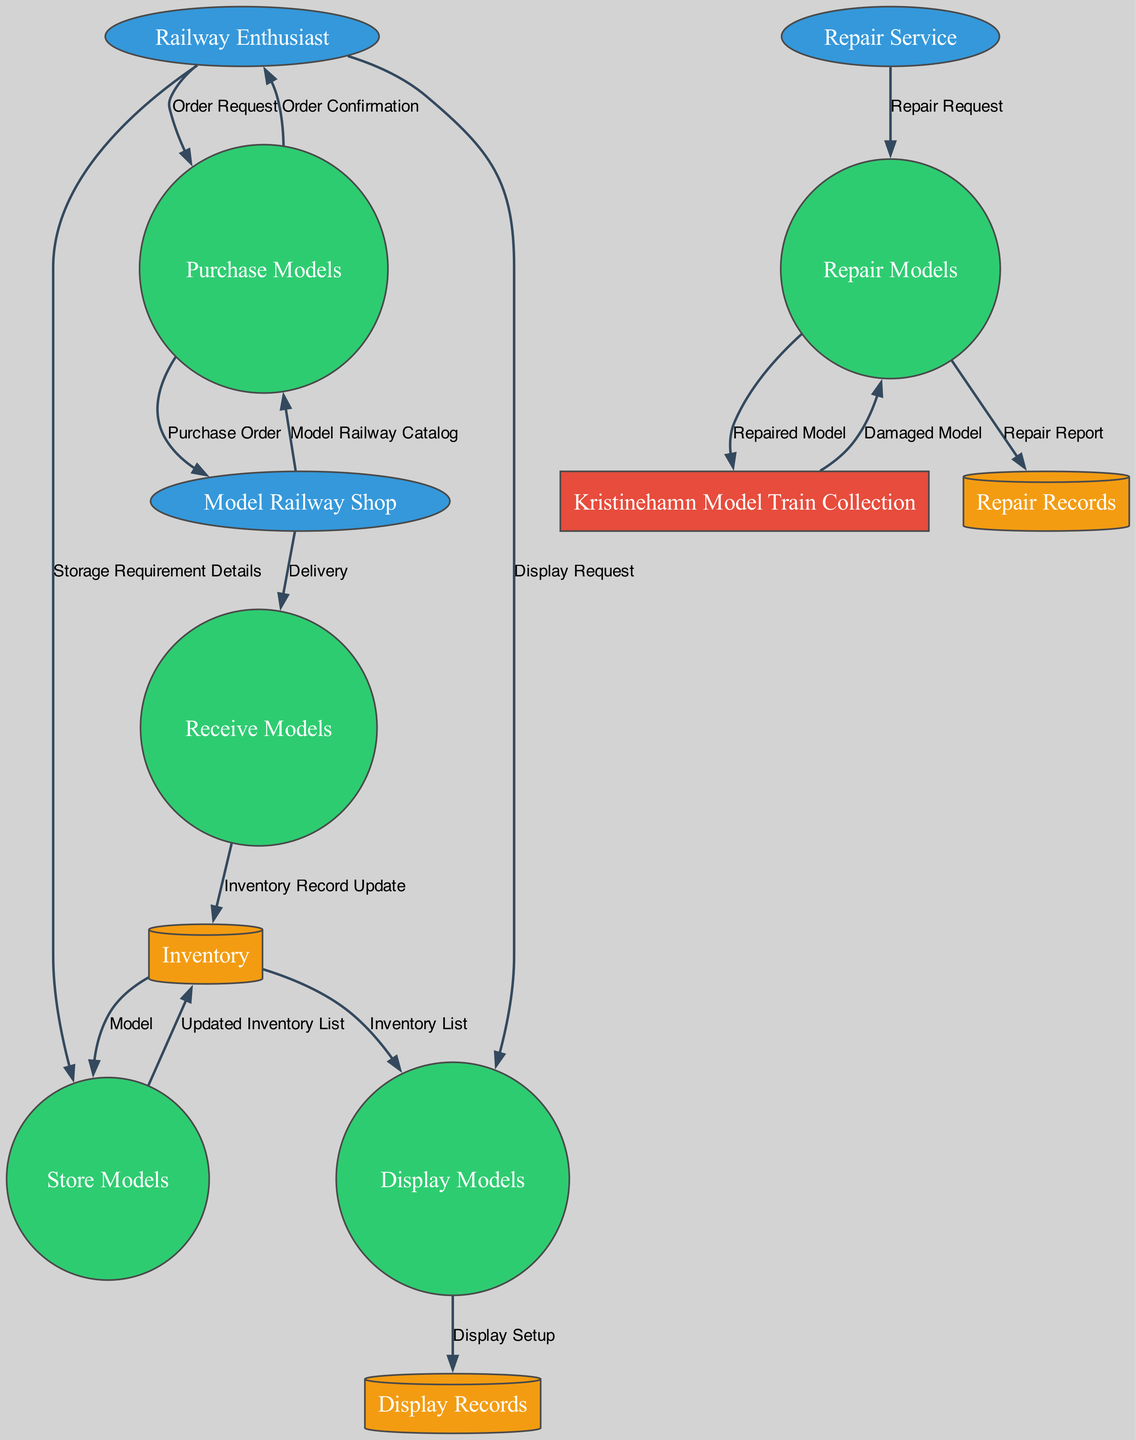What are the external entities in the diagram? The diagram has three external entities: Railway Enthusiast, Model Railway Shop, and Repair Service. Each of these entities has interactions with the processes for managing the model railway collection.
Answer: Railway Enthusiast, Model Railway Shop, Repair Service How many processes are there in the diagram? There are five processes in the diagram: Purchase Models, Receive Models, Repair Models, Display Models, and Store Models. Each process represents a specific operation in managing the railway collection.
Answer: Five What does the "Purchase Models" process output? The "Purchase Models" process outputs two items: "Order Confirmation to Railway Enthusiast" and "Purchase Order to Model Railway Shop." These outputs signify the completion of the purchasing process.
Answer: Order Confirmation to Railway Enthusiast, Purchase Order to Model Railway Shop Which process receives the "Repair Request"? The "Repair Models" process receives the "Repair Request" input from the "Repair Service." This indicates that the repair service is initiating a request for model repairs.
Answer: Repair Models How does a damaged model get repaired in this system? The damaged model from the "Kristinehamn Model Train Collection" flows into the "Repair Models" process, where a "Repair Request" is also involved. After repair, the output is the "Repaired Model" back to the collection, along with a "Repair Report."
Answer: Through the Repair Models process What is the main role of the "Inventory" data store? The "Inventory" data store acts as a central repository that updates and maintains records of both inventory and damaged models. It supports the various processes by providing necessary inputs and receiving outputs.
Answer: To maintain inventory records Which external entity initiates the display request? The display request is initiated by the "Railway Enthusiast," who communicates their interest to see the models. This input connects to the "Display Models" process, indicating a desire for display setup.
Answer: Railway Enthusiast What type of data store is used for storing repair records? The data store for storing repair records is a "Repair Records" store, which holds the outputs from the "Repair Models" process in the form of "Repair Report."
Answer: Repair Records How does the "Store Models" process interact with the "Inventory"? The "Store Models" process takes models from the "Inventory" and returns an "Updated Inventory List" to the same store. This interaction ensures that the inventory reflects current storage conditions.
Answer: By taking models and returning an updated list 